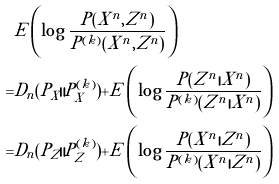<formula> <loc_0><loc_0><loc_500><loc_500>& E \left ( \log \frac { P ( X ^ { n } , Z ^ { n } ) } { P ^ { ( k ) } ( X ^ { n } , Z ^ { n } ) } \right ) \\ = & D _ { n } ( P _ { X } \| P _ { X } ^ { ( k ) } ) + E \left ( \log \frac { P ( Z ^ { n } | X ^ { n } ) } { P ^ { ( k ) } ( Z ^ { n } | X ^ { n } ) } \right ) \\ = & D _ { n } ( P _ { Z } \| P _ { Z } ^ { ( k ) } ) + E \left ( \log \frac { P ( X ^ { n } | Z ^ { n } ) } { P ^ { ( k ) } ( X ^ { n } | Z ^ { n } ) } \right )</formula> 